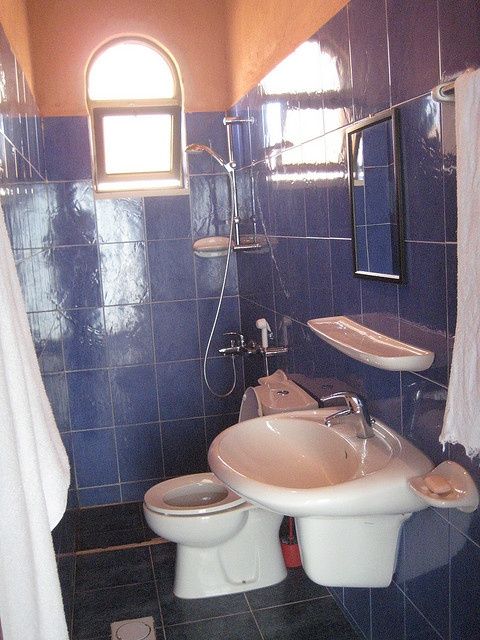Describe the objects in this image and their specific colors. I can see sink in tan, lightgray, darkgray, and salmon tones and toilet in tan, darkgray, lightgray, and gray tones in this image. 